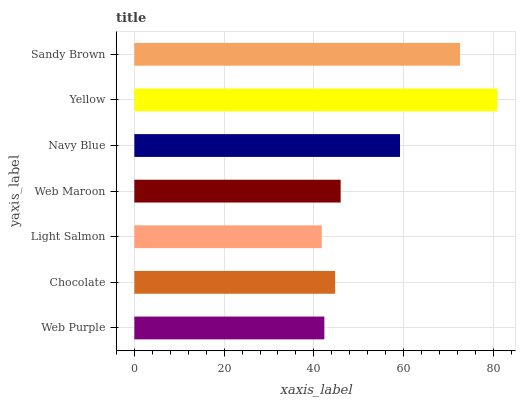Is Light Salmon the minimum?
Answer yes or no. Yes. Is Yellow the maximum?
Answer yes or no. Yes. Is Chocolate the minimum?
Answer yes or no. No. Is Chocolate the maximum?
Answer yes or no. No. Is Chocolate greater than Web Purple?
Answer yes or no. Yes. Is Web Purple less than Chocolate?
Answer yes or no. Yes. Is Web Purple greater than Chocolate?
Answer yes or no. No. Is Chocolate less than Web Purple?
Answer yes or no. No. Is Web Maroon the high median?
Answer yes or no. Yes. Is Web Maroon the low median?
Answer yes or no. Yes. Is Sandy Brown the high median?
Answer yes or no. No. Is Light Salmon the low median?
Answer yes or no. No. 